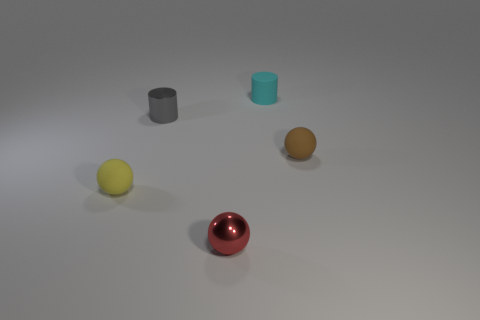What size is the cyan cylinder that is the same material as the yellow sphere?
Give a very brief answer. Small. What shape is the metallic thing behind the brown thing?
Ensure brevity in your answer.  Cylinder. What is the size of the other thing that is the same shape as the tiny cyan matte thing?
Offer a terse response. Small. What number of tiny things are in front of the small matte ball that is to the right of the tiny rubber cylinder that is right of the tiny yellow thing?
Your answer should be compact. 2. Are there an equal number of tiny red metallic objects behind the tiny gray object and large purple cylinders?
Offer a terse response. Yes. What number of cylinders are either small gray objects or tiny objects?
Ensure brevity in your answer.  2. Does the tiny metallic cylinder have the same color as the tiny metallic sphere?
Provide a succinct answer. No. Are there the same number of small red things that are on the left side of the small metal sphere and tiny gray cylinders that are behind the small gray cylinder?
Your answer should be compact. Yes. What is the color of the rubber cylinder?
Offer a very short reply. Cyan. How many objects are tiny rubber objects in front of the cyan cylinder or shiny balls?
Keep it short and to the point. 3. 